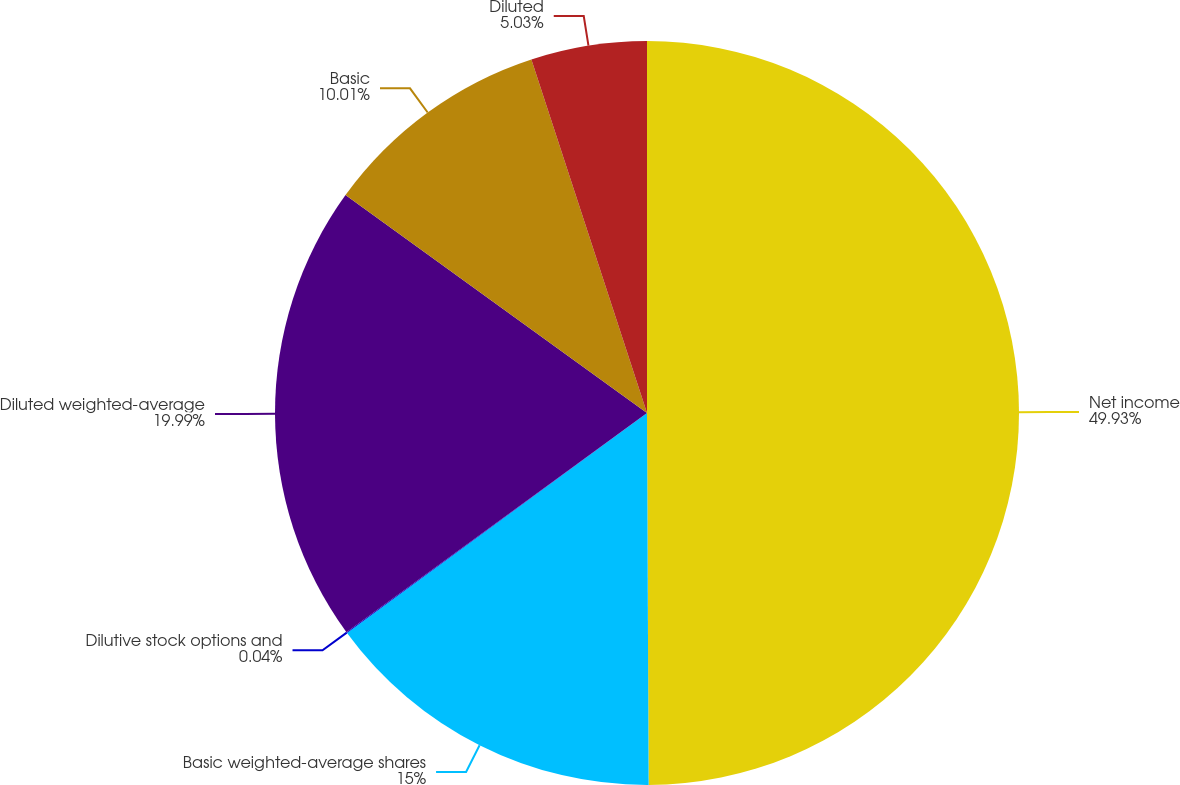Convert chart. <chart><loc_0><loc_0><loc_500><loc_500><pie_chart><fcel>Net income<fcel>Basic weighted-average shares<fcel>Dilutive stock options and<fcel>Diluted weighted-average<fcel>Basic<fcel>Diluted<nl><fcel>49.93%<fcel>15.0%<fcel>0.04%<fcel>19.99%<fcel>10.01%<fcel>5.03%<nl></chart> 